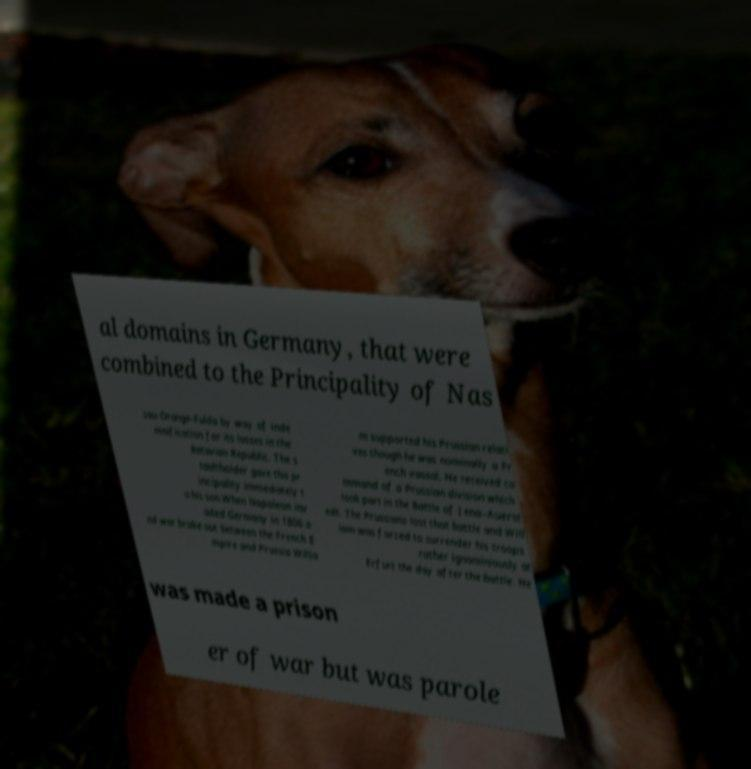Could you extract and type out the text from this image? al domains in Germany, that were combined to the Principality of Nas sau-Orange-Fulda by way of inde mnification for its losses in the Batavian Republic. The s tadtholder gave this pr incipality immediately t o his son.When Napoleon inv aded Germany in 1806 a nd war broke out between the French E mpire and Prussia Willia m supported his Prussian relati ves though he was nominally a Fr ench vassal. He received co mmand of a Prussian division which took part in the Battle of Jena–Auerst edt. The Prussians lost that battle and Will iam was forced to surrender his troops rather ignominiously at Erfurt the day after the battle. He was made a prison er of war but was parole 